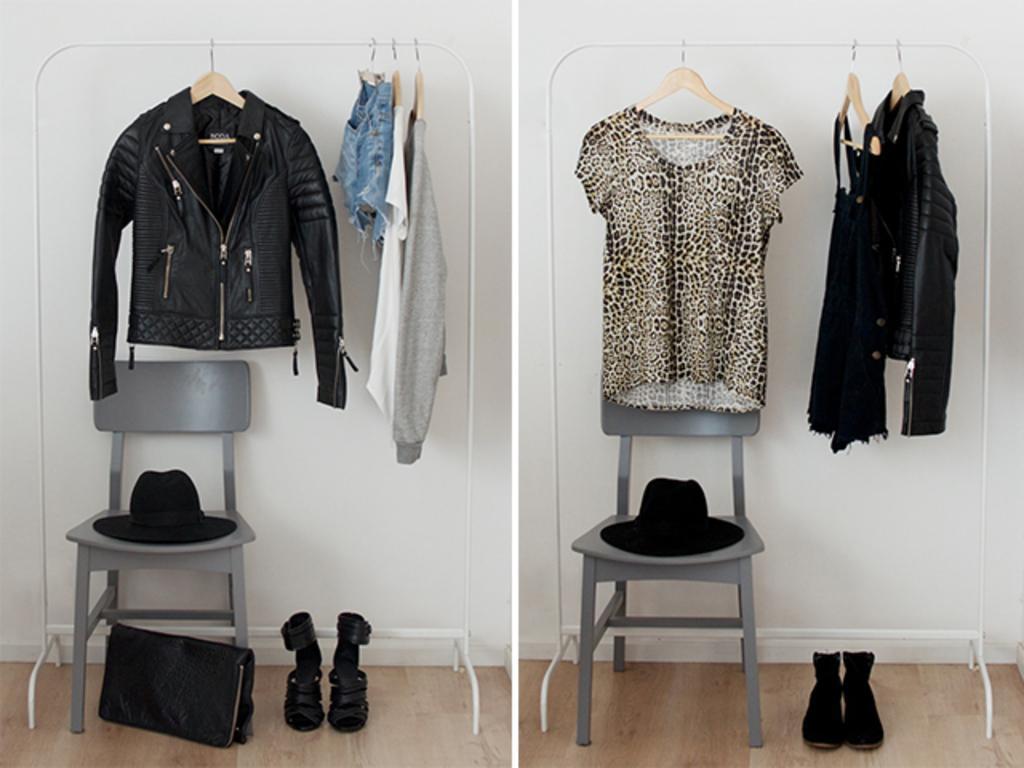How would you summarize this image in a sentence or two? In the image we can see the collage photos. In it we can see the clothes hang to the hangers. We can even see the chair and on the chair there is a hat. Here we can see wooden floor and we can even see the boots.  